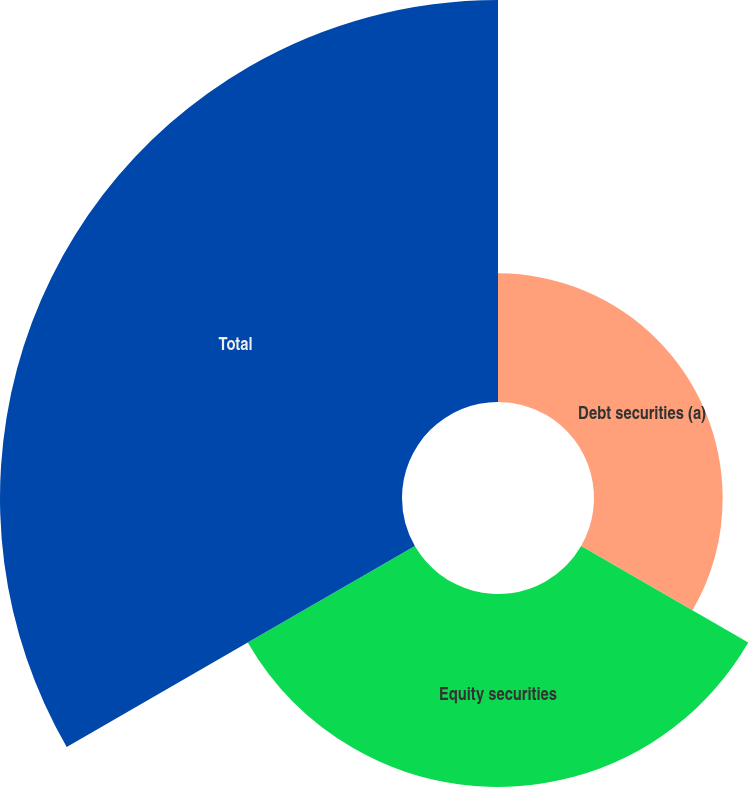Convert chart. <chart><loc_0><loc_0><loc_500><loc_500><pie_chart><fcel>Debt securities (a)<fcel>Equity securities<fcel>Total<nl><fcel>17.78%<fcel>26.67%<fcel>55.56%<nl></chart> 